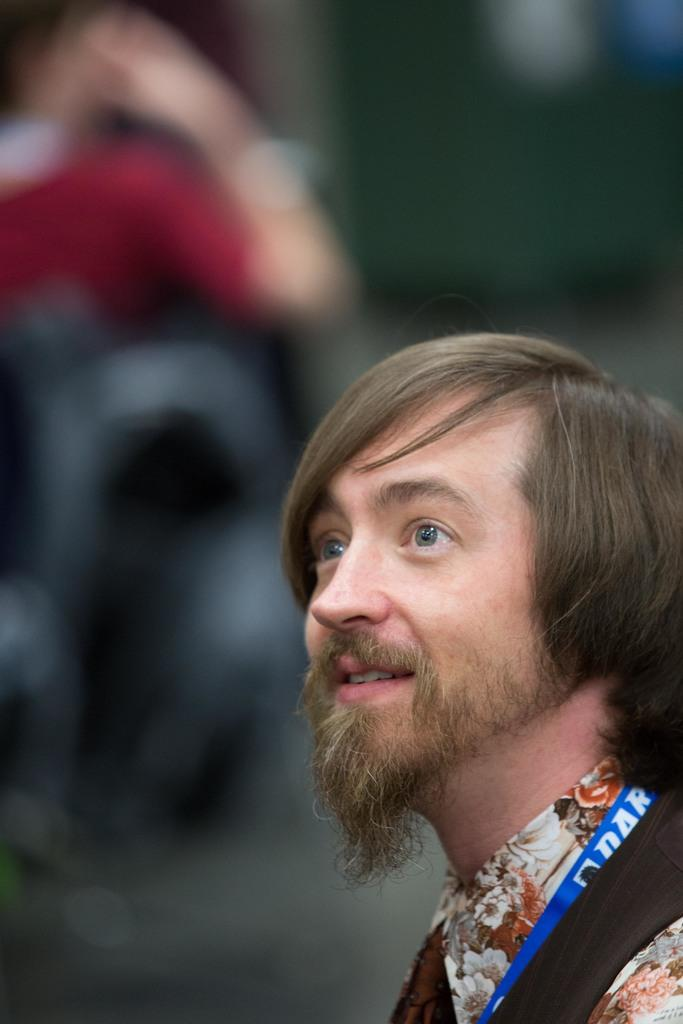What is present on the right side of the image? There is a person in the image, and they are on the right side. Can you describe the background of the image? The background of the image is blurred. What type of pancake is the person holding in the image? There is no pancake present in the image, and the person is not holding anything. How many shoes can be seen on the person's feet in the image? There is no reference to shoes or feet in the image, so it's not possible to determine how many shoes might be present. 